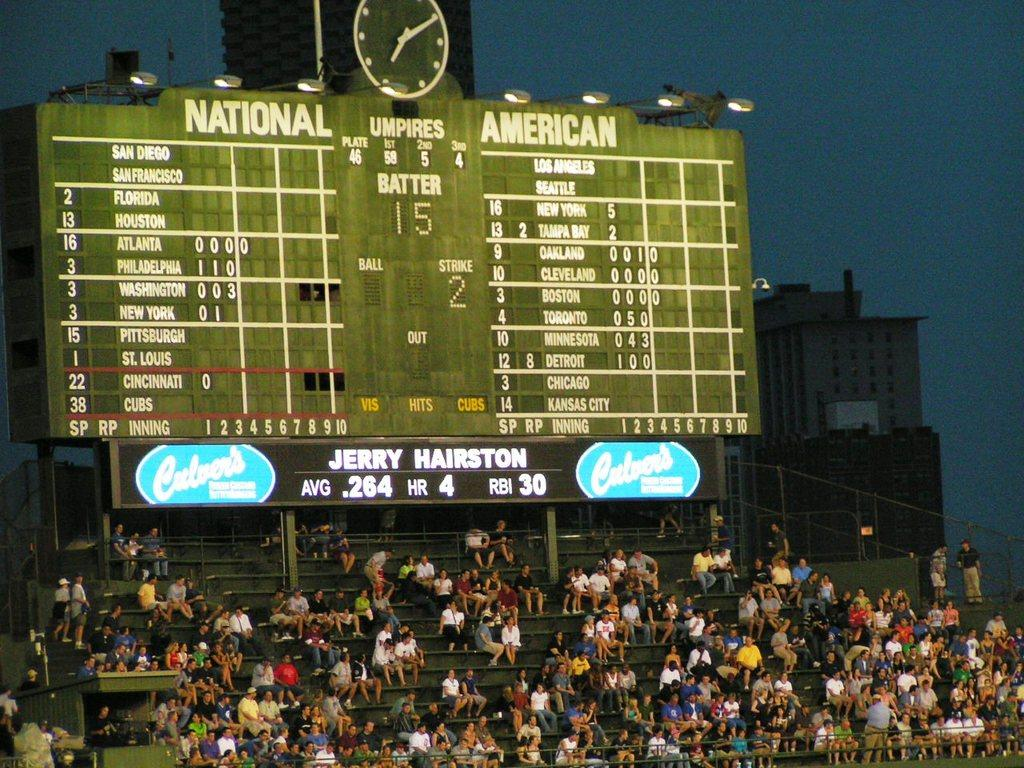<image>
Present a compact description of the photo's key features. Scoreboard with the National and American League teams. At bat is Jerry Hairston Avg.264, HR 4, and RBI 30. 